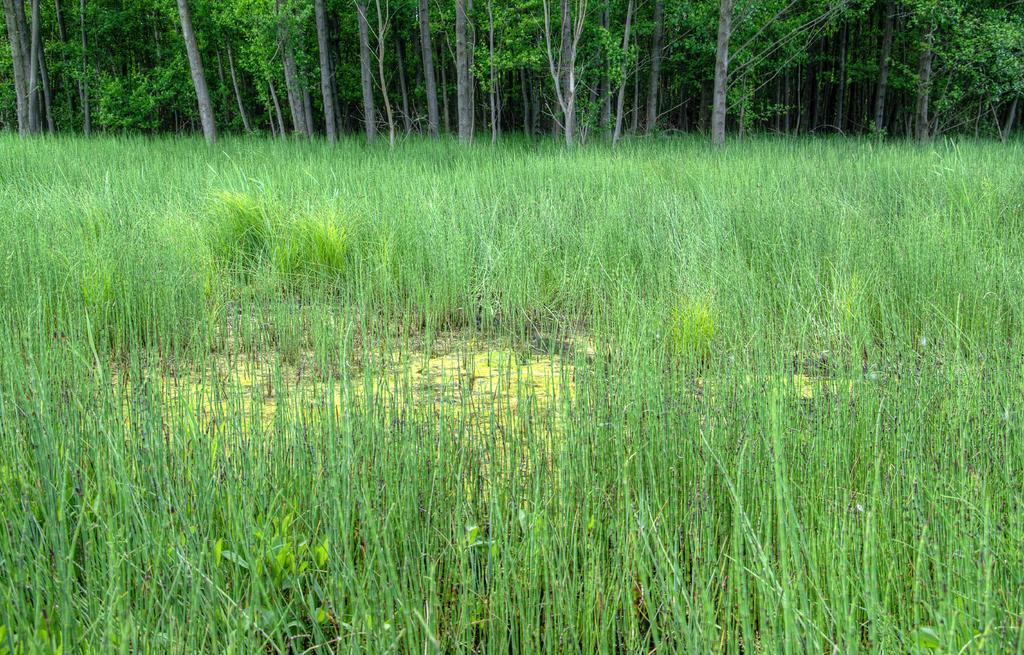What type of location is depicted in the image? There is an agricultural farm in the image. What can be seen at the top of the image? There are trees at the top of the image. How many giants are visible in the image? There are no giants present in the image. What type of plantation can be seen in the image? The image does not depict a plantation; it shows an agricultural farm. 